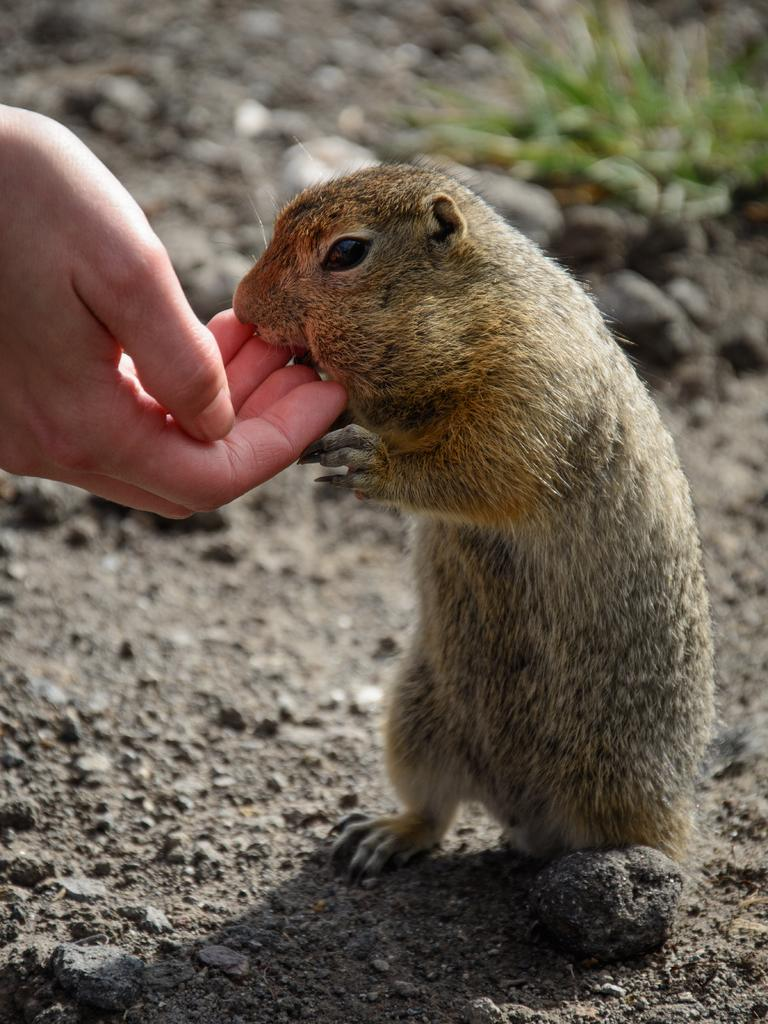What type of creature is present in the image? There is an animal in the image. Can you describe the color of the animal? The animal is brown in color. What else can be seen in the image besides the animal? There is a person's hand and mud visible in the image. How would you describe the background of the image? The background of the image is blurred. How many pizzas can be seen in the image? There are no pizzas present in the image. What type of hammer is being used by the animal in the image? There is no hammer present in the image; it features an animal, a person's hand, and mud. 